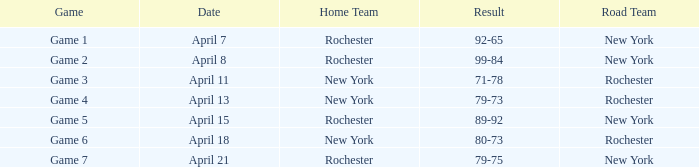Which Road Team has a Home Team of rochester, and a Result of 89-92? New York. 